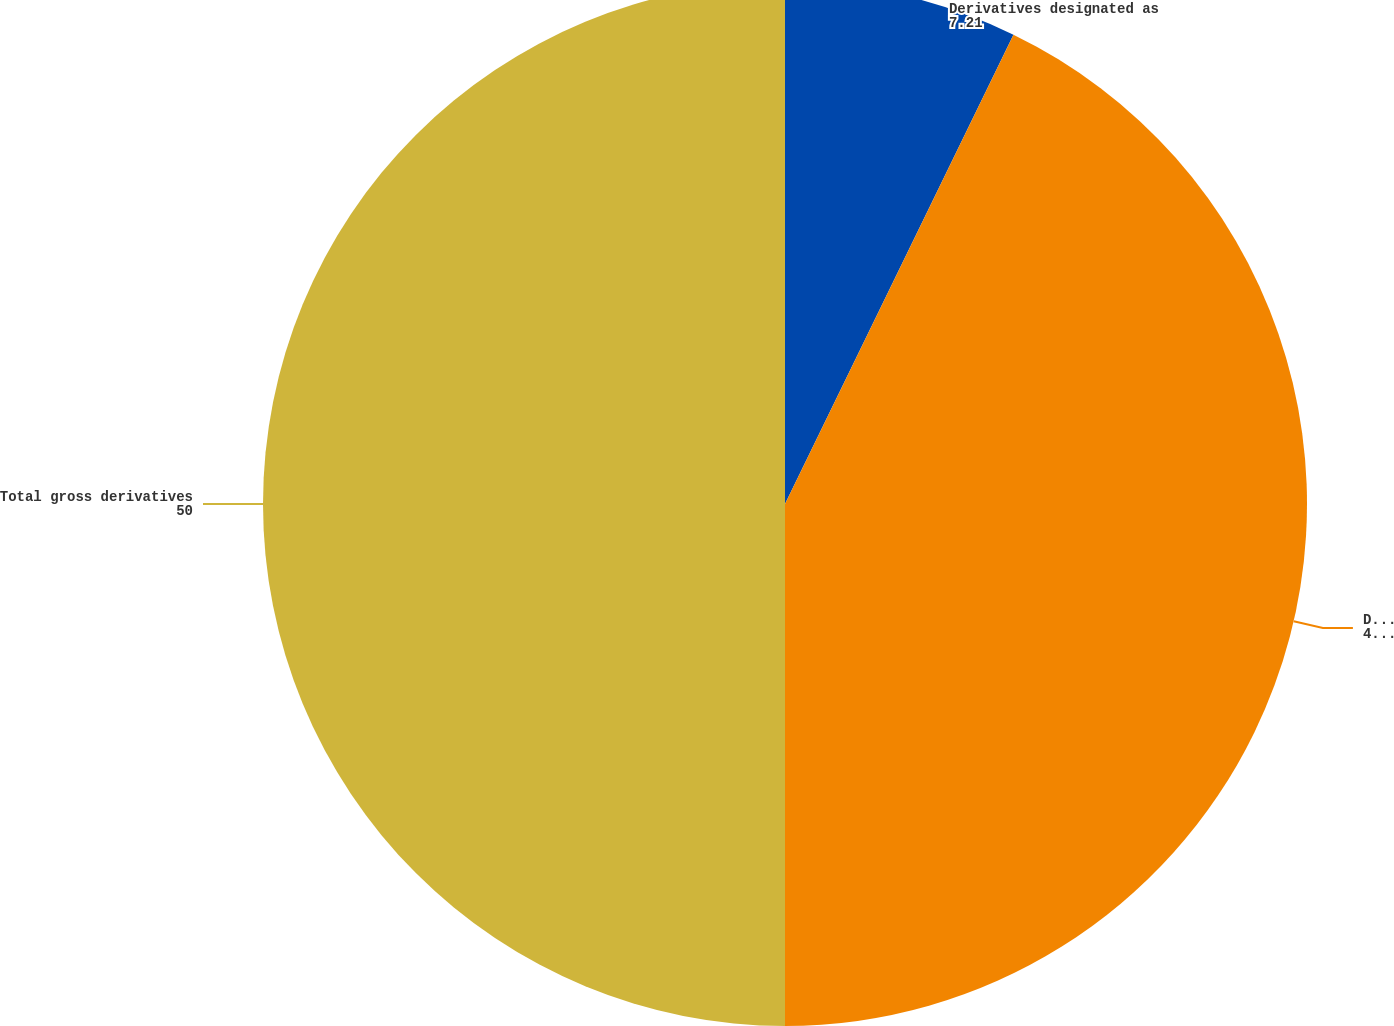Convert chart to OTSL. <chart><loc_0><loc_0><loc_500><loc_500><pie_chart><fcel>Derivatives designated as<fcel>Derivatives not designated as<fcel>Total gross derivatives<nl><fcel>7.21%<fcel>42.79%<fcel>50.0%<nl></chart> 